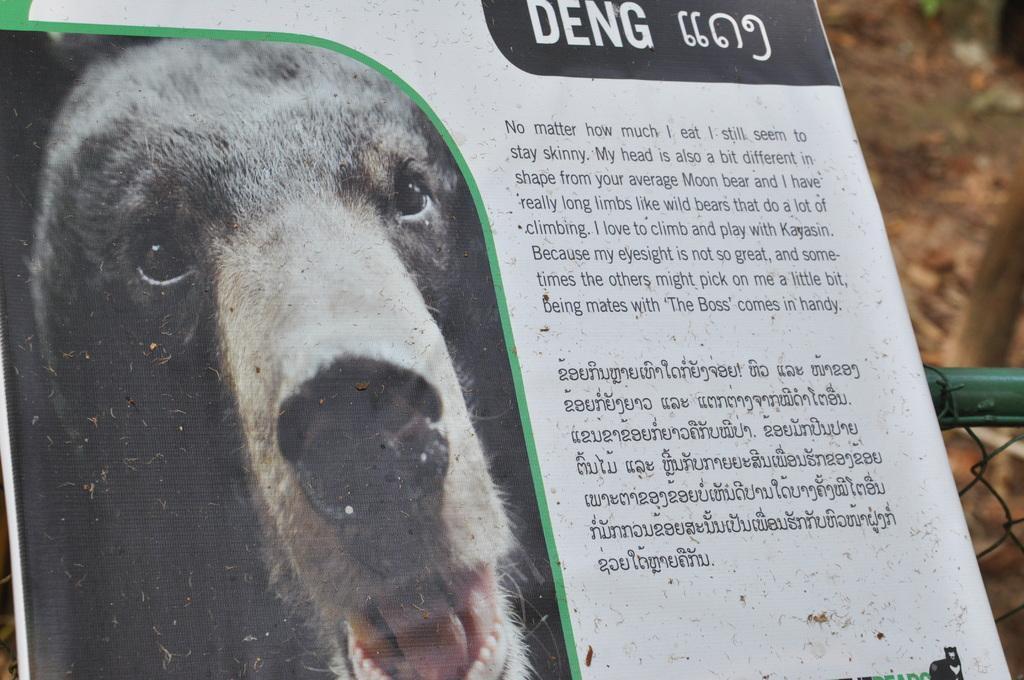Describe this image in one or two sentences. In the middle of the image there is a poster with an image of an animal and there is a text on it. In the background there is a ground and there is a fence. 